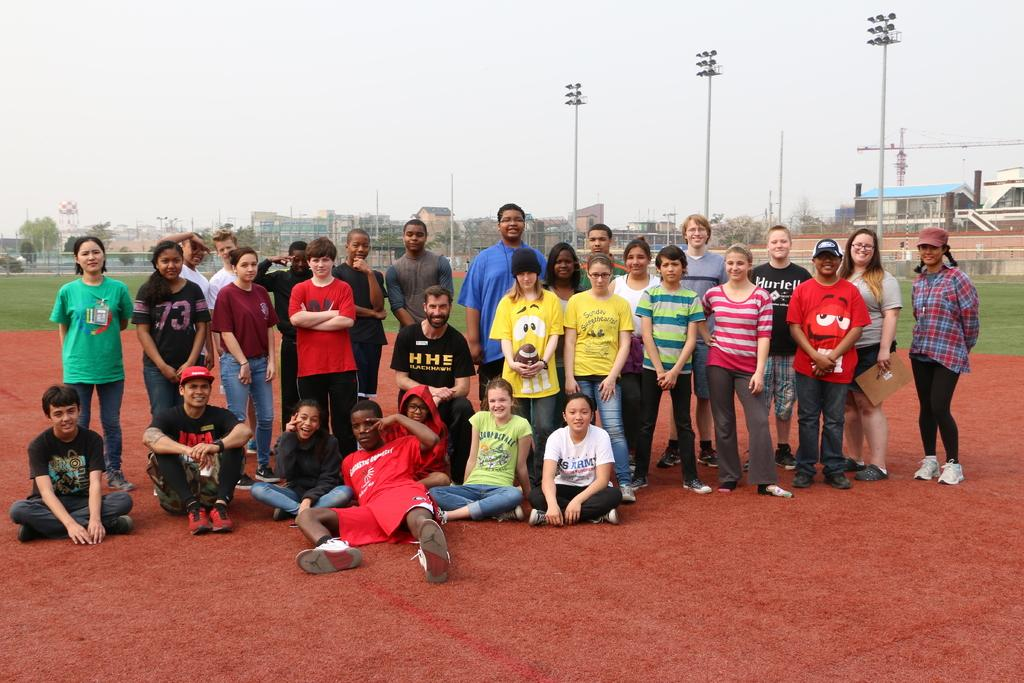What are the people in the image doing? There are people standing and sitting on the ground in the image. What can be seen on the poles in the image? There are flood lights on poles in the image. What structures are visible in the image? There are buildings visible in the image. What type of vegetation is present in the image? There are trees in the image. What is the condition of the sky in the background of the image? The sky is cloudy in the background of the image. What type of zephyr can be seen blowing through the trees in the image? There is no zephyr present in the image; it is a still image with no indication of wind or breeze. What is the relation between the people and the buildings in the image? The provided facts do not give any information about the relationship between the people and the buildings in the image. 